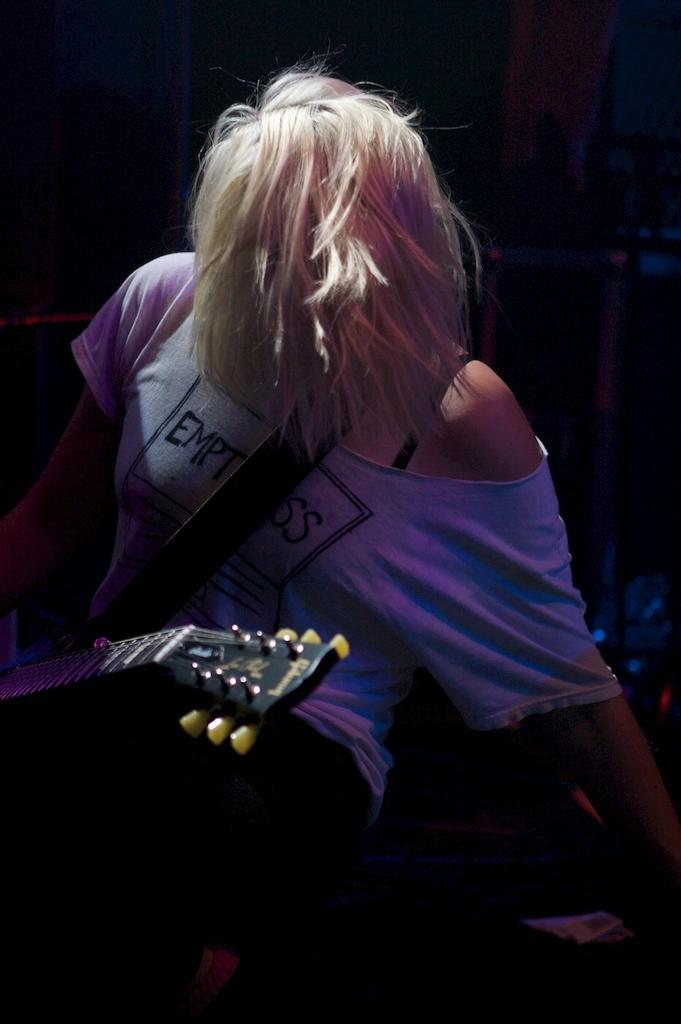Who is the main subject in the image? There is a girl in the image. What is the girl doing in the image? The girl is sitting. What is the girl holding in the image? The girl is carrying a music instrument. What is the color of the music instrument? The music instrument is black in color. What type of competition is the girl participating in in the image? There is no competition present in the image; it only shows a girl sitting with a black music instrument. 